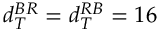<formula> <loc_0><loc_0><loc_500><loc_500>d _ { T } ^ { B R } = d _ { T } ^ { R B } = 1 6</formula> 